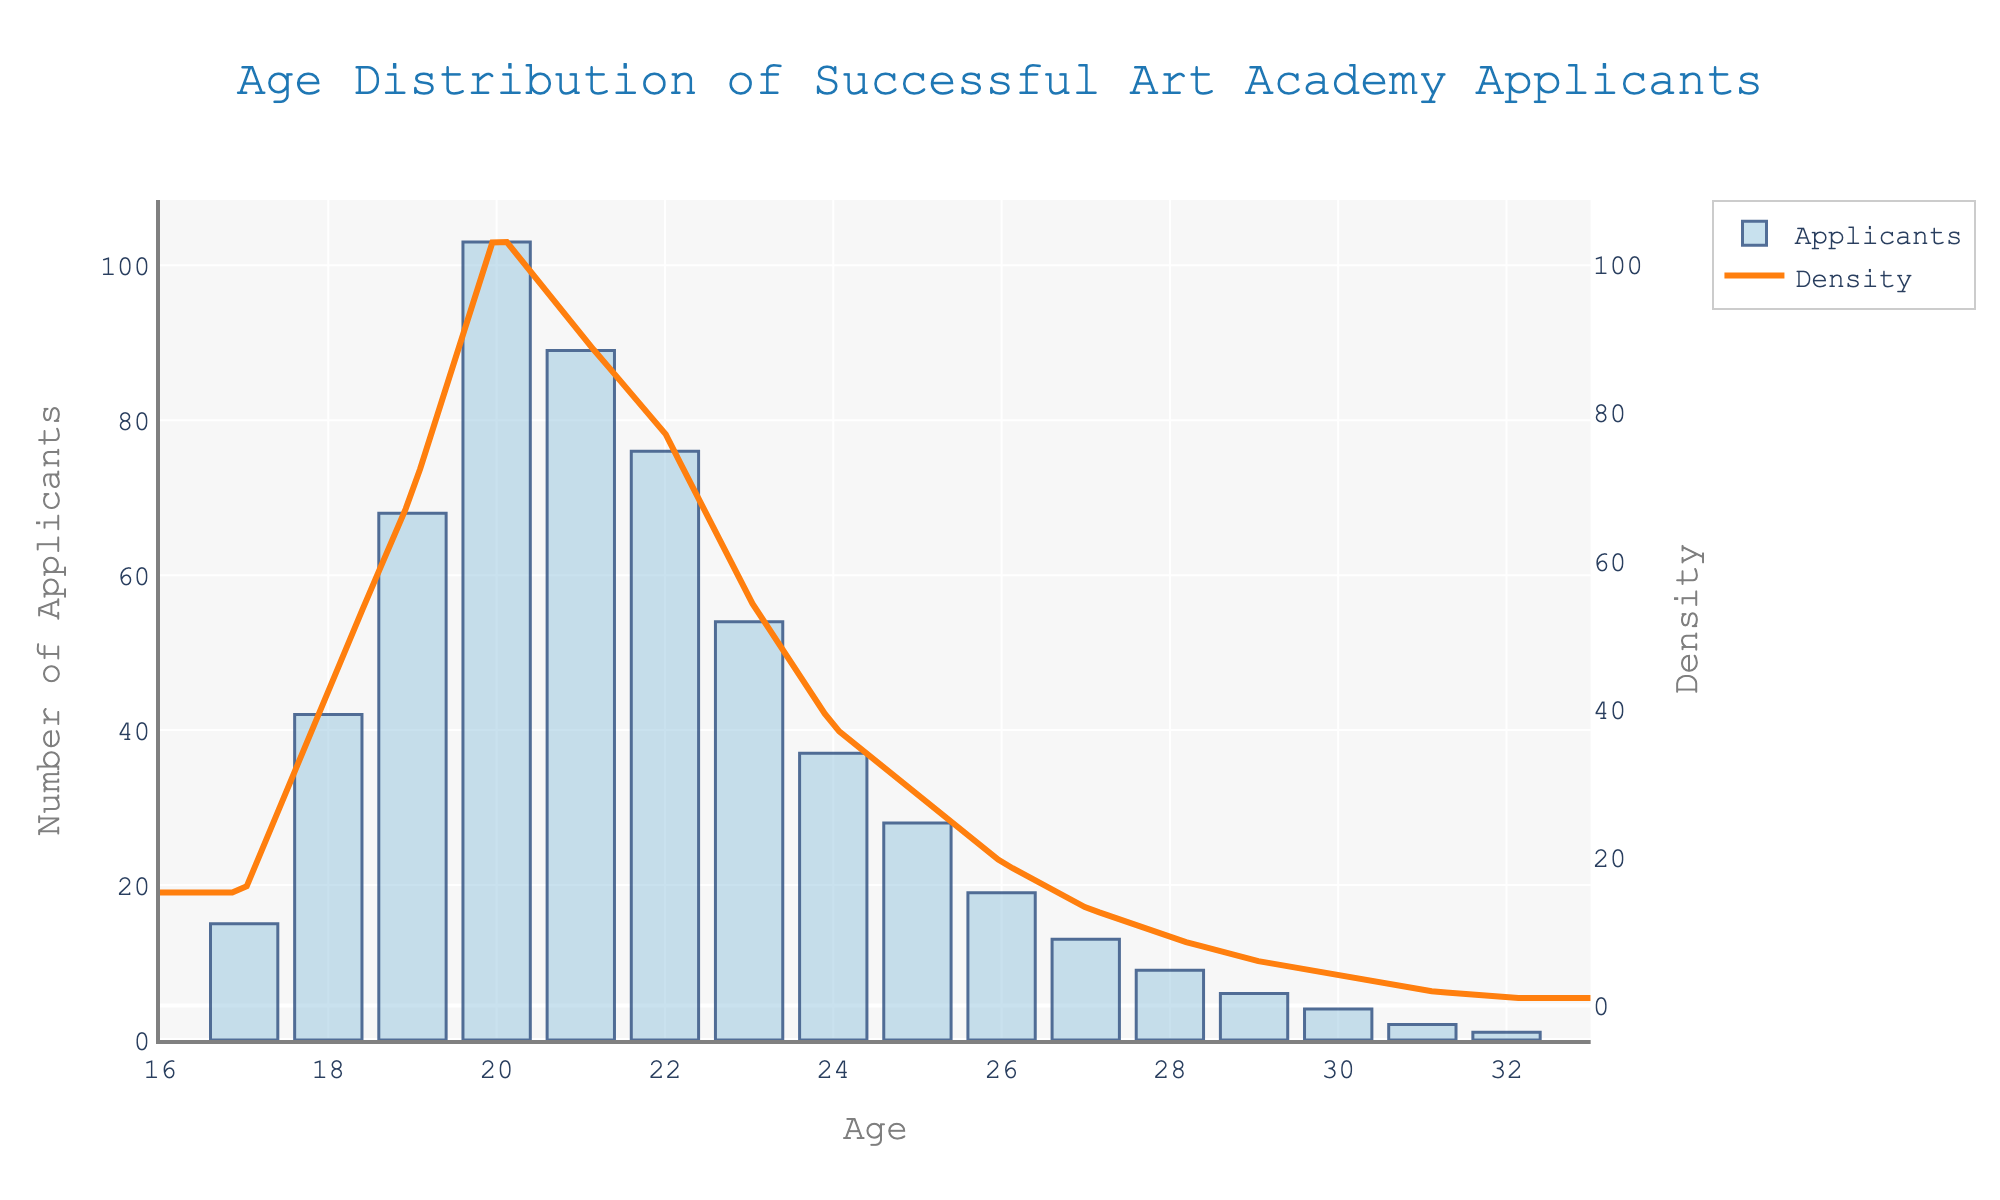What is the most frequent age among successful applicants? The histogram shows the number of applicants for each age, and the age with the highest bar represents the most frequent age. Here, the age 20 has the highest bar with 103 applicants.
Answer: 20 How many successful applicants were 23 years old? To find the number of 23-year-old applicants, refer to the bar corresponding to age 23 on the histogram. The count is 54.
Answer: 54 Which age has a higher number of successful applicants, 21 or 25? Compare the heights of the bars for ages 21 and 25 on the histogram. Age 21 has 89 applicants while age 25 has 28 applicants, so age 21 has more successful applicants.
Answer: 21 What is the range of ages of the successful applicants? The age range is determined by subtracting the youngest age from the oldest age. The youngest age is 17 and the oldest is 32, so the range is 32 - 17.
Answer: 15 What does the peak of the density curve indicate? The peak of the density curve represents the age where the distribution of successful applicants is most concentrated. The peak occurs around age 20, indicating that most successful applicants are around this age.
Answer: Age 20 How does the number of successful applicants aged 18 compare to those aged 24? Compare the heights of the histogram bars for ages 18 and 24. Age 18 has 42 applicants, while age 24 has 37 applicants, so there are more successful applicants aged 18.
Answer: 18 What is the total number of successful applicants aged between 19 and 23 (inclusive)? Sum the counts of applicants aged 19, 20, 21, 22, and 23 from the histogram. 68 + 103 + 89 + 76 + 54 = 390.
Answer: 390 At what age does the density curve start to decline significantly? Observe the density curve for where it begins to move downwards after the peak. It starts to decline significantly after age 20.
Answer: 20 Which age group shows a higher density, age 18 or age 26? Compare the density values on the density curve for ages 18 and 26. The density around age 18 is higher compared to age 26.
Answer: Age 18 How many applicants were older than 30 years old? Sum the counts of applicants aged 31 and 32. 2 + 1 = 3.
Answer: 3 